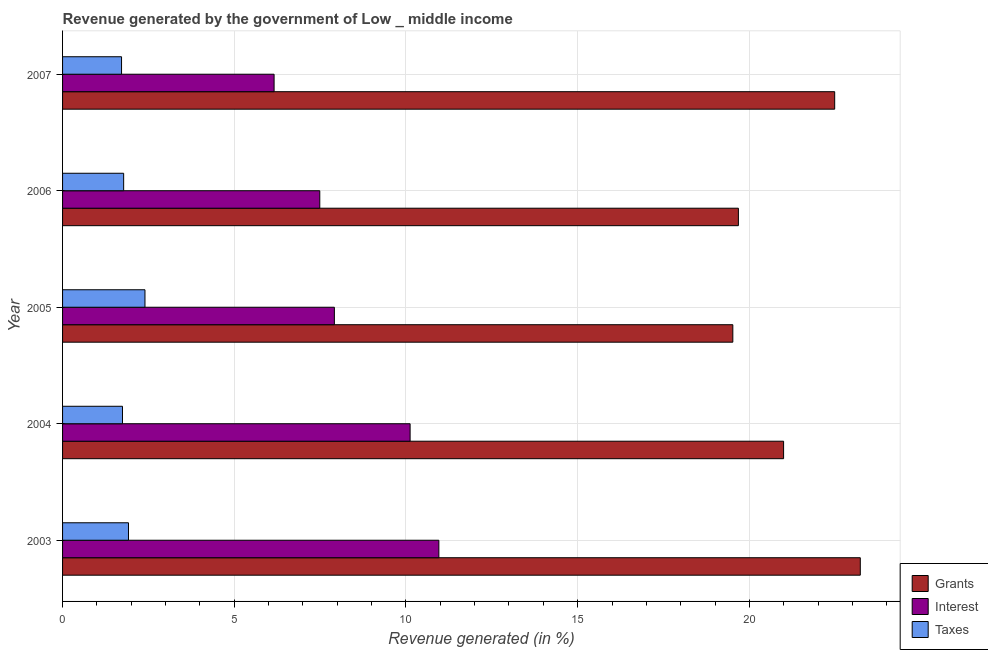Are the number of bars per tick equal to the number of legend labels?
Provide a succinct answer. Yes. Are the number of bars on each tick of the Y-axis equal?
Keep it short and to the point. Yes. How many bars are there on the 5th tick from the bottom?
Ensure brevity in your answer.  3. What is the label of the 3rd group of bars from the top?
Offer a terse response. 2005. What is the percentage of revenue generated by interest in 2003?
Give a very brief answer. 10.96. Across all years, what is the maximum percentage of revenue generated by grants?
Make the answer very short. 23.23. Across all years, what is the minimum percentage of revenue generated by taxes?
Give a very brief answer. 1.72. In which year was the percentage of revenue generated by taxes minimum?
Provide a short and direct response. 2007. What is the total percentage of revenue generated by grants in the graph?
Your answer should be compact. 105.91. What is the difference between the percentage of revenue generated by taxes in 2003 and that in 2006?
Ensure brevity in your answer.  0.14. What is the difference between the percentage of revenue generated by grants in 2007 and the percentage of revenue generated by taxes in 2003?
Offer a very short reply. 20.57. What is the average percentage of revenue generated by taxes per year?
Keep it short and to the point. 1.91. In the year 2003, what is the difference between the percentage of revenue generated by taxes and percentage of revenue generated by interest?
Provide a succinct answer. -9.04. In how many years, is the percentage of revenue generated by grants greater than 21 %?
Ensure brevity in your answer.  2. What is the ratio of the percentage of revenue generated by grants in 2006 to that in 2007?
Give a very brief answer. 0.88. What is the difference between the highest and the second highest percentage of revenue generated by taxes?
Your answer should be compact. 0.48. What is the difference between the highest and the lowest percentage of revenue generated by taxes?
Make the answer very short. 0.68. What does the 1st bar from the top in 2003 represents?
Your response must be concise. Taxes. What does the 2nd bar from the bottom in 2005 represents?
Keep it short and to the point. Interest. How many years are there in the graph?
Your answer should be compact. 5. Does the graph contain grids?
Provide a succinct answer. Yes. Where does the legend appear in the graph?
Keep it short and to the point. Bottom right. How many legend labels are there?
Give a very brief answer. 3. What is the title of the graph?
Provide a succinct answer. Revenue generated by the government of Low _ middle income. What is the label or title of the X-axis?
Your answer should be compact. Revenue generated (in %). What is the label or title of the Y-axis?
Give a very brief answer. Year. What is the Revenue generated (in %) of Grants in 2003?
Your answer should be compact. 23.23. What is the Revenue generated (in %) in Interest in 2003?
Keep it short and to the point. 10.96. What is the Revenue generated (in %) of Taxes in 2003?
Your answer should be very brief. 1.92. What is the Revenue generated (in %) of Grants in 2004?
Provide a succinct answer. 21. What is the Revenue generated (in %) of Interest in 2004?
Your response must be concise. 10.12. What is the Revenue generated (in %) of Taxes in 2004?
Provide a succinct answer. 1.75. What is the Revenue generated (in %) of Grants in 2005?
Make the answer very short. 19.52. What is the Revenue generated (in %) in Interest in 2005?
Offer a terse response. 7.92. What is the Revenue generated (in %) in Taxes in 2005?
Your answer should be very brief. 2.4. What is the Revenue generated (in %) in Grants in 2006?
Keep it short and to the point. 19.68. What is the Revenue generated (in %) of Interest in 2006?
Your response must be concise. 7.49. What is the Revenue generated (in %) of Taxes in 2006?
Offer a terse response. 1.78. What is the Revenue generated (in %) of Grants in 2007?
Ensure brevity in your answer.  22.48. What is the Revenue generated (in %) of Interest in 2007?
Ensure brevity in your answer.  6.16. What is the Revenue generated (in %) in Taxes in 2007?
Give a very brief answer. 1.72. Across all years, what is the maximum Revenue generated (in %) of Grants?
Offer a terse response. 23.23. Across all years, what is the maximum Revenue generated (in %) of Interest?
Ensure brevity in your answer.  10.96. Across all years, what is the maximum Revenue generated (in %) in Taxes?
Offer a very short reply. 2.4. Across all years, what is the minimum Revenue generated (in %) in Grants?
Ensure brevity in your answer.  19.52. Across all years, what is the minimum Revenue generated (in %) in Interest?
Offer a terse response. 6.16. Across all years, what is the minimum Revenue generated (in %) in Taxes?
Offer a terse response. 1.72. What is the total Revenue generated (in %) of Grants in the graph?
Your answer should be compact. 105.91. What is the total Revenue generated (in %) of Interest in the graph?
Offer a very short reply. 42.64. What is the total Revenue generated (in %) of Taxes in the graph?
Give a very brief answer. 9.56. What is the difference between the Revenue generated (in %) of Grants in 2003 and that in 2004?
Your answer should be very brief. 2.23. What is the difference between the Revenue generated (in %) of Interest in 2003 and that in 2004?
Make the answer very short. 0.84. What is the difference between the Revenue generated (in %) of Taxes in 2003 and that in 2004?
Your answer should be compact. 0.17. What is the difference between the Revenue generated (in %) in Grants in 2003 and that in 2005?
Ensure brevity in your answer.  3.71. What is the difference between the Revenue generated (in %) of Interest in 2003 and that in 2005?
Offer a very short reply. 3.04. What is the difference between the Revenue generated (in %) of Taxes in 2003 and that in 2005?
Provide a short and direct response. -0.48. What is the difference between the Revenue generated (in %) of Grants in 2003 and that in 2006?
Provide a succinct answer. 3.55. What is the difference between the Revenue generated (in %) of Interest in 2003 and that in 2006?
Your answer should be very brief. 3.47. What is the difference between the Revenue generated (in %) in Taxes in 2003 and that in 2006?
Your answer should be compact. 0.14. What is the difference between the Revenue generated (in %) of Grants in 2003 and that in 2007?
Your answer should be compact. 0.75. What is the difference between the Revenue generated (in %) of Interest in 2003 and that in 2007?
Make the answer very short. 4.8. What is the difference between the Revenue generated (in %) of Taxes in 2003 and that in 2007?
Your answer should be compact. 0.2. What is the difference between the Revenue generated (in %) of Grants in 2004 and that in 2005?
Provide a succinct answer. 1.48. What is the difference between the Revenue generated (in %) of Interest in 2004 and that in 2005?
Keep it short and to the point. 2.21. What is the difference between the Revenue generated (in %) in Taxes in 2004 and that in 2005?
Your answer should be very brief. -0.65. What is the difference between the Revenue generated (in %) in Grants in 2004 and that in 2006?
Offer a very short reply. 1.32. What is the difference between the Revenue generated (in %) of Interest in 2004 and that in 2006?
Give a very brief answer. 2.63. What is the difference between the Revenue generated (in %) of Taxes in 2004 and that in 2006?
Keep it short and to the point. -0.03. What is the difference between the Revenue generated (in %) of Grants in 2004 and that in 2007?
Ensure brevity in your answer.  -1.49. What is the difference between the Revenue generated (in %) of Interest in 2004 and that in 2007?
Make the answer very short. 3.96. What is the difference between the Revenue generated (in %) in Taxes in 2004 and that in 2007?
Offer a terse response. 0.03. What is the difference between the Revenue generated (in %) in Grants in 2005 and that in 2006?
Provide a succinct answer. -0.16. What is the difference between the Revenue generated (in %) of Interest in 2005 and that in 2006?
Provide a short and direct response. 0.43. What is the difference between the Revenue generated (in %) of Taxes in 2005 and that in 2006?
Offer a terse response. 0.62. What is the difference between the Revenue generated (in %) in Grants in 2005 and that in 2007?
Provide a succinct answer. -2.97. What is the difference between the Revenue generated (in %) in Interest in 2005 and that in 2007?
Provide a succinct answer. 1.76. What is the difference between the Revenue generated (in %) of Taxes in 2005 and that in 2007?
Your answer should be very brief. 0.68. What is the difference between the Revenue generated (in %) in Grants in 2006 and that in 2007?
Ensure brevity in your answer.  -2.8. What is the difference between the Revenue generated (in %) in Interest in 2006 and that in 2007?
Your response must be concise. 1.33. What is the difference between the Revenue generated (in %) in Taxes in 2006 and that in 2007?
Offer a very short reply. 0.06. What is the difference between the Revenue generated (in %) in Grants in 2003 and the Revenue generated (in %) in Interest in 2004?
Keep it short and to the point. 13.11. What is the difference between the Revenue generated (in %) of Grants in 2003 and the Revenue generated (in %) of Taxes in 2004?
Keep it short and to the point. 21.49. What is the difference between the Revenue generated (in %) in Interest in 2003 and the Revenue generated (in %) in Taxes in 2004?
Your response must be concise. 9.21. What is the difference between the Revenue generated (in %) of Grants in 2003 and the Revenue generated (in %) of Interest in 2005?
Give a very brief answer. 15.31. What is the difference between the Revenue generated (in %) in Grants in 2003 and the Revenue generated (in %) in Taxes in 2005?
Offer a terse response. 20.83. What is the difference between the Revenue generated (in %) of Interest in 2003 and the Revenue generated (in %) of Taxes in 2005?
Your answer should be compact. 8.56. What is the difference between the Revenue generated (in %) of Grants in 2003 and the Revenue generated (in %) of Interest in 2006?
Your answer should be very brief. 15.74. What is the difference between the Revenue generated (in %) in Grants in 2003 and the Revenue generated (in %) in Taxes in 2006?
Keep it short and to the point. 21.45. What is the difference between the Revenue generated (in %) in Interest in 2003 and the Revenue generated (in %) in Taxes in 2006?
Your answer should be compact. 9.18. What is the difference between the Revenue generated (in %) of Grants in 2003 and the Revenue generated (in %) of Interest in 2007?
Your response must be concise. 17.07. What is the difference between the Revenue generated (in %) of Grants in 2003 and the Revenue generated (in %) of Taxes in 2007?
Keep it short and to the point. 21.51. What is the difference between the Revenue generated (in %) of Interest in 2003 and the Revenue generated (in %) of Taxes in 2007?
Keep it short and to the point. 9.24. What is the difference between the Revenue generated (in %) of Grants in 2004 and the Revenue generated (in %) of Interest in 2005?
Offer a terse response. 13.08. What is the difference between the Revenue generated (in %) in Grants in 2004 and the Revenue generated (in %) in Taxes in 2005?
Make the answer very short. 18.6. What is the difference between the Revenue generated (in %) of Interest in 2004 and the Revenue generated (in %) of Taxes in 2005?
Your answer should be compact. 7.72. What is the difference between the Revenue generated (in %) of Grants in 2004 and the Revenue generated (in %) of Interest in 2006?
Offer a terse response. 13.51. What is the difference between the Revenue generated (in %) in Grants in 2004 and the Revenue generated (in %) in Taxes in 2006?
Provide a short and direct response. 19.22. What is the difference between the Revenue generated (in %) in Interest in 2004 and the Revenue generated (in %) in Taxes in 2006?
Your answer should be compact. 8.34. What is the difference between the Revenue generated (in %) of Grants in 2004 and the Revenue generated (in %) of Interest in 2007?
Give a very brief answer. 14.84. What is the difference between the Revenue generated (in %) of Grants in 2004 and the Revenue generated (in %) of Taxes in 2007?
Provide a short and direct response. 19.28. What is the difference between the Revenue generated (in %) in Interest in 2004 and the Revenue generated (in %) in Taxes in 2007?
Provide a short and direct response. 8.4. What is the difference between the Revenue generated (in %) of Grants in 2005 and the Revenue generated (in %) of Interest in 2006?
Provide a succinct answer. 12.03. What is the difference between the Revenue generated (in %) of Grants in 2005 and the Revenue generated (in %) of Taxes in 2006?
Offer a terse response. 17.74. What is the difference between the Revenue generated (in %) of Interest in 2005 and the Revenue generated (in %) of Taxes in 2006?
Keep it short and to the point. 6.14. What is the difference between the Revenue generated (in %) of Grants in 2005 and the Revenue generated (in %) of Interest in 2007?
Give a very brief answer. 13.36. What is the difference between the Revenue generated (in %) in Grants in 2005 and the Revenue generated (in %) in Taxes in 2007?
Give a very brief answer. 17.8. What is the difference between the Revenue generated (in %) in Interest in 2005 and the Revenue generated (in %) in Taxes in 2007?
Give a very brief answer. 6.2. What is the difference between the Revenue generated (in %) of Grants in 2006 and the Revenue generated (in %) of Interest in 2007?
Your answer should be very brief. 13.52. What is the difference between the Revenue generated (in %) in Grants in 2006 and the Revenue generated (in %) in Taxes in 2007?
Offer a very short reply. 17.96. What is the difference between the Revenue generated (in %) of Interest in 2006 and the Revenue generated (in %) of Taxes in 2007?
Your answer should be very brief. 5.77. What is the average Revenue generated (in %) of Grants per year?
Keep it short and to the point. 21.18. What is the average Revenue generated (in %) in Interest per year?
Ensure brevity in your answer.  8.53. What is the average Revenue generated (in %) of Taxes per year?
Offer a very short reply. 1.91. In the year 2003, what is the difference between the Revenue generated (in %) of Grants and Revenue generated (in %) of Interest?
Make the answer very short. 12.27. In the year 2003, what is the difference between the Revenue generated (in %) of Grants and Revenue generated (in %) of Taxes?
Offer a terse response. 21.31. In the year 2003, what is the difference between the Revenue generated (in %) in Interest and Revenue generated (in %) in Taxes?
Your answer should be very brief. 9.04. In the year 2004, what is the difference between the Revenue generated (in %) of Grants and Revenue generated (in %) of Interest?
Keep it short and to the point. 10.88. In the year 2004, what is the difference between the Revenue generated (in %) in Grants and Revenue generated (in %) in Taxes?
Provide a succinct answer. 19.25. In the year 2004, what is the difference between the Revenue generated (in %) in Interest and Revenue generated (in %) in Taxes?
Your response must be concise. 8.38. In the year 2005, what is the difference between the Revenue generated (in %) in Grants and Revenue generated (in %) in Interest?
Offer a terse response. 11.6. In the year 2005, what is the difference between the Revenue generated (in %) of Grants and Revenue generated (in %) of Taxes?
Your answer should be very brief. 17.12. In the year 2005, what is the difference between the Revenue generated (in %) in Interest and Revenue generated (in %) in Taxes?
Your answer should be very brief. 5.52. In the year 2006, what is the difference between the Revenue generated (in %) of Grants and Revenue generated (in %) of Interest?
Give a very brief answer. 12.19. In the year 2006, what is the difference between the Revenue generated (in %) in Grants and Revenue generated (in %) in Taxes?
Give a very brief answer. 17.9. In the year 2006, what is the difference between the Revenue generated (in %) of Interest and Revenue generated (in %) of Taxes?
Make the answer very short. 5.71. In the year 2007, what is the difference between the Revenue generated (in %) of Grants and Revenue generated (in %) of Interest?
Make the answer very short. 16.32. In the year 2007, what is the difference between the Revenue generated (in %) of Grants and Revenue generated (in %) of Taxes?
Ensure brevity in your answer.  20.77. In the year 2007, what is the difference between the Revenue generated (in %) of Interest and Revenue generated (in %) of Taxes?
Give a very brief answer. 4.44. What is the ratio of the Revenue generated (in %) in Grants in 2003 to that in 2004?
Your answer should be compact. 1.11. What is the ratio of the Revenue generated (in %) in Interest in 2003 to that in 2004?
Your answer should be very brief. 1.08. What is the ratio of the Revenue generated (in %) in Taxes in 2003 to that in 2004?
Ensure brevity in your answer.  1.1. What is the ratio of the Revenue generated (in %) in Grants in 2003 to that in 2005?
Ensure brevity in your answer.  1.19. What is the ratio of the Revenue generated (in %) in Interest in 2003 to that in 2005?
Your response must be concise. 1.38. What is the ratio of the Revenue generated (in %) in Taxes in 2003 to that in 2005?
Your answer should be very brief. 0.8. What is the ratio of the Revenue generated (in %) of Grants in 2003 to that in 2006?
Give a very brief answer. 1.18. What is the ratio of the Revenue generated (in %) in Interest in 2003 to that in 2006?
Your answer should be very brief. 1.46. What is the ratio of the Revenue generated (in %) of Taxes in 2003 to that in 2006?
Provide a short and direct response. 1.08. What is the ratio of the Revenue generated (in %) of Grants in 2003 to that in 2007?
Make the answer very short. 1.03. What is the ratio of the Revenue generated (in %) of Interest in 2003 to that in 2007?
Offer a terse response. 1.78. What is the ratio of the Revenue generated (in %) of Taxes in 2003 to that in 2007?
Your answer should be very brief. 1.12. What is the ratio of the Revenue generated (in %) of Grants in 2004 to that in 2005?
Provide a succinct answer. 1.08. What is the ratio of the Revenue generated (in %) of Interest in 2004 to that in 2005?
Your response must be concise. 1.28. What is the ratio of the Revenue generated (in %) of Taxes in 2004 to that in 2005?
Provide a short and direct response. 0.73. What is the ratio of the Revenue generated (in %) in Grants in 2004 to that in 2006?
Your answer should be very brief. 1.07. What is the ratio of the Revenue generated (in %) of Interest in 2004 to that in 2006?
Provide a succinct answer. 1.35. What is the ratio of the Revenue generated (in %) of Taxes in 2004 to that in 2006?
Provide a short and direct response. 0.98. What is the ratio of the Revenue generated (in %) of Grants in 2004 to that in 2007?
Make the answer very short. 0.93. What is the ratio of the Revenue generated (in %) in Interest in 2004 to that in 2007?
Provide a short and direct response. 1.64. What is the ratio of the Revenue generated (in %) of Interest in 2005 to that in 2006?
Offer a very short reply. 1.06. What is the ratio of the Revenue generated (in %) of Taxes in 2005 to that in 2006?
Make the answer very short. 1.35. What is the ratio of the Revenue generated (in %) in Grants in 2005 to that in 2007?
Make the answer very short. 0.87. What is the ratio of the Revenue generated (in %) of Interest in 2005 to that in 2007?
Provide a succinct answer. 1.28. What is the ratio of the Revenue generated (in %) in Taxes in 2005 to that in 2007?
Provide a succinct answer. 1.4. What is the ratio of the Revenue generated (in %) of Grants in 2006 to that in 2007?
Provide a short and direct response. 0.88. What is the ratio of the Revenue generated (in %) of Interest in 2006 to that in 2007?
Keep it short and to the point. 1.22. What is the ratio of the Revenue generated (in %) in Taxes in 2006 to that in 2007?
Ensure brevity in your answer.  1.04. What is the difference between the highest and the second highest Revenue generated (in %) of Grants?
Keep it short and to the point. 0.75. What is the difference between the highest and the second highest Revenue generated (in %) in Interest?
Provide a short and direct response. 0.84. What is the difference between the highest and the second highest Revenue generated (in %) in Taxes?
Ensure brevity in your answer.  0.48. What is the difference between the highest and the lowest Revenue generated (in %) of Grants?
Provide a succinct answer. 3.71. What is the difference between the highest and the lowest Revenue generated (in %) in Interest?
Provide a succinct answer. 4.8. What is the difference between the highest and the lowest Revenue generated (in %) in Taxes?
Your answer should be compact. 0.68. 